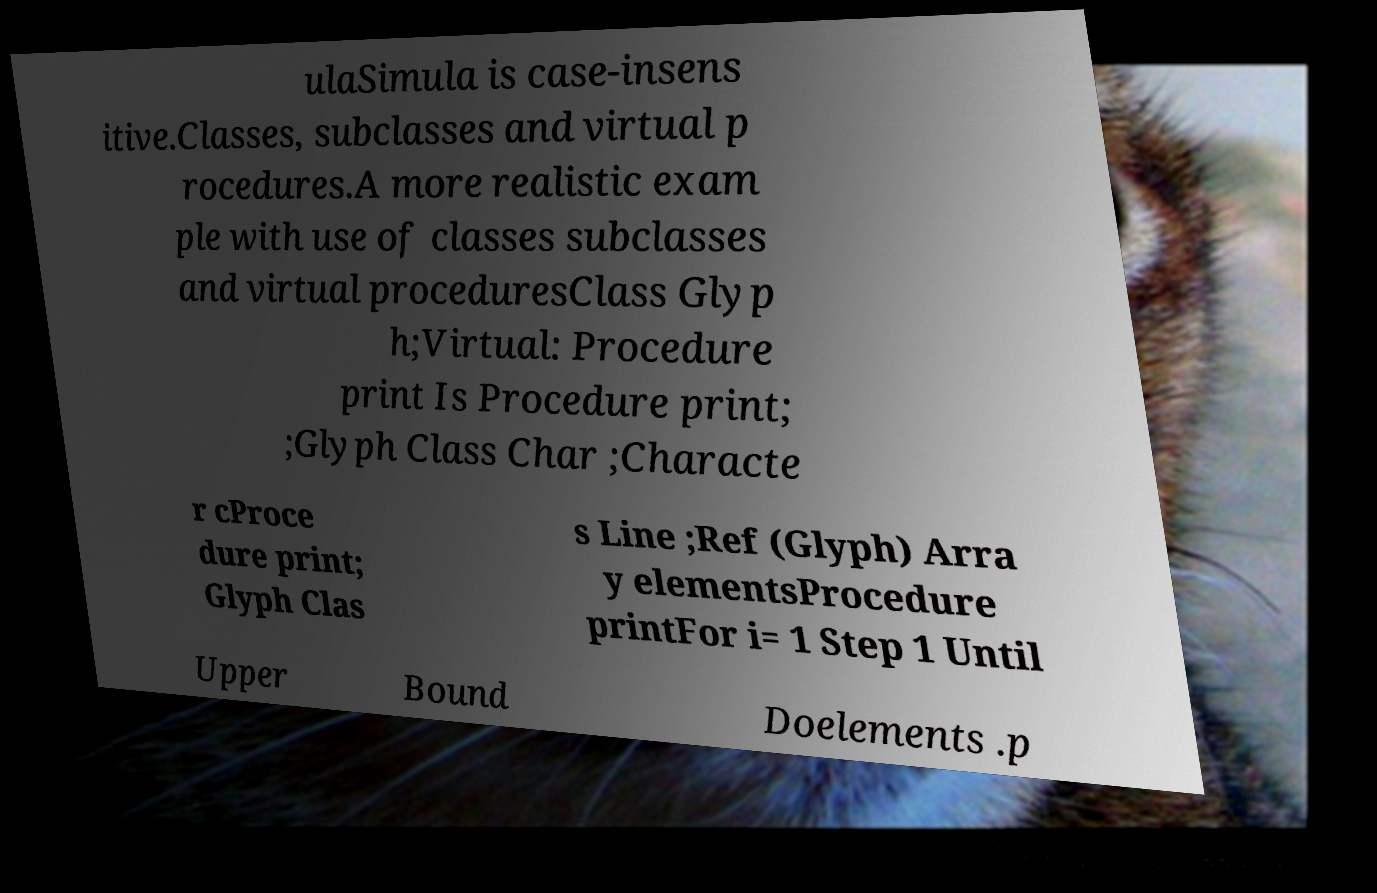Please identify and transcribe the text found in this image. ulaSimula is case-insens itive.Classes, subclasses and virtual p rocedures.A more realistic exam ple with use of classes subclasses and virtual proceduresClass Glyp h;Virtual: Procedure print Is Procedure print; ;Glyph Class Char ;Characte r cProce dure print; Glyph Clas s Line ;Ref (Glyph) Arra y elementsProcedure printFor i= 1 Step 1 Until Upper Bound Doelements .p 